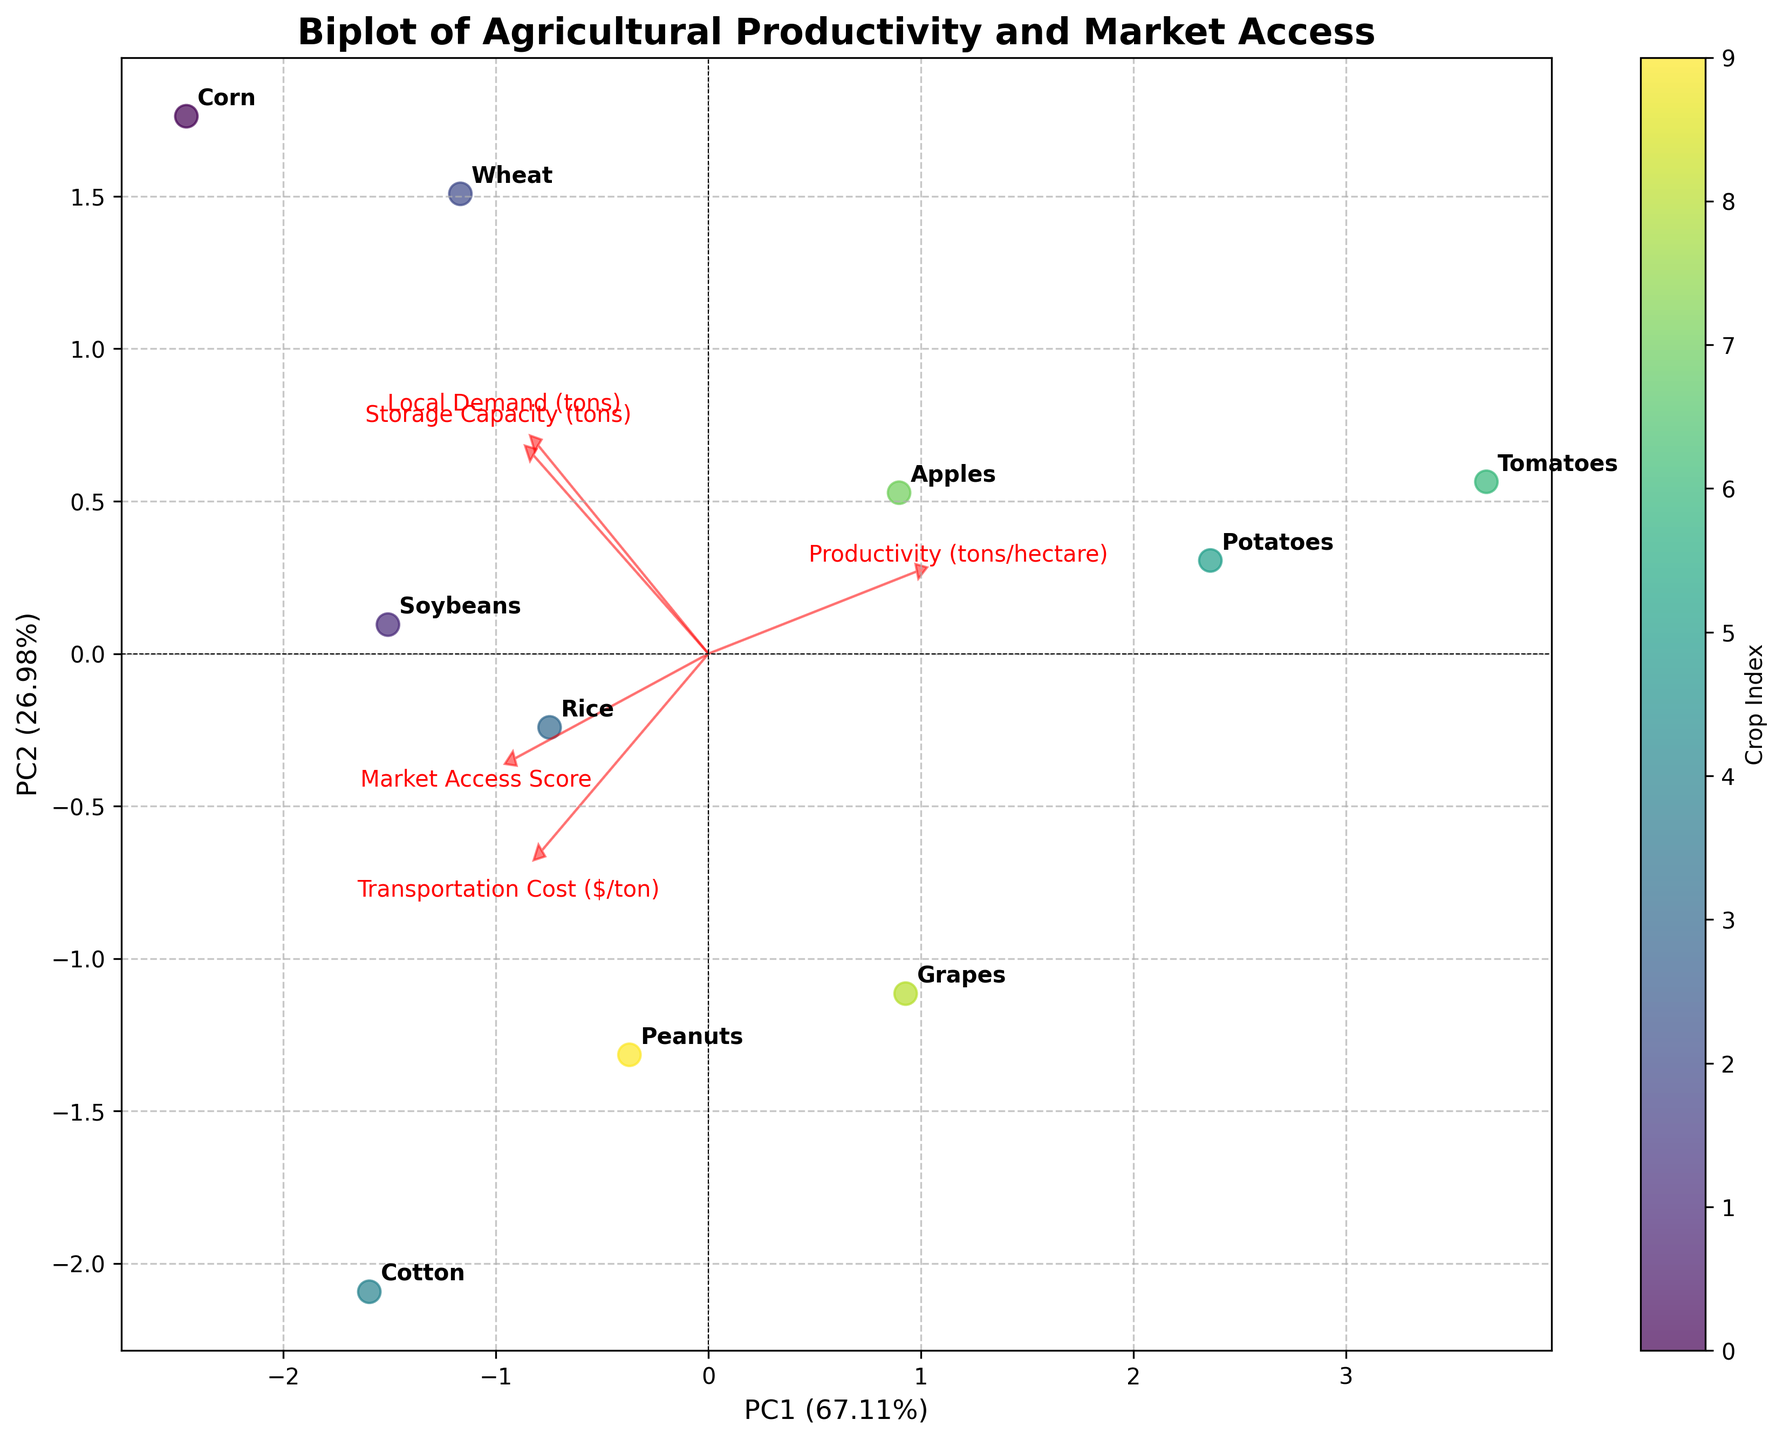What's the title of the figure? The title is usually placed at the top of the figure. From the description, the title is mentioned to be "Biplot of Agricultural Productivity and Market Access".
Answer: Biplot of Agricultural Productivity and Market Access What do the X and Y axes represent? The X-axis and Y-axis labels indicate Principal Components (PC1 and PC2). The exact text will be in the format “PC1 (percentage)” and “PC2 (percentage)”, reflecting the explained variance. From the code details, PC1 and PC2 are the leading components.
Answer: PC1 and PC2 Which crop appears to have the highest productivity? Crops are represented in the biplot with their names. A crop label that is farthest along the direction of the "Productivity" vector can be inferred as having high productivity. For this problem, "Tomatoes" is the crop with the highest productivity.
Answer: Tomatoes What crop has the lowest market access score? This can be determined by checking the crop label closest to the origin along the "Market Access Score" vector. From the data, "Tomatoes" have the lowest score.
Answer: Tomatoes Is there a crop that is closer to the origin in the biplot plot? If so, which one? The crop closest to the origin of the biplot can be seen as having average values for all the factors, where it manifests neither strong nor weak attributes in any direction. Comparing distances, it appears "Peanuts" are closest.
Answer: Peanuts Which principal component explains the most variance in the data? The labels on the X and Y axes typically denote explained variances, e.g., "PC1 (40%)". By comparing these labels, the principal component with the higher percentage denotes the one explaining more variance.
Answer: PC1 Which crop type has the highest local demand? The crops positioned farthest along the "Local Demand" vector in the biplot should have the highest local demand. According to the data, "Corn" has the highest local demand.
Answer: Corn How does transportation cost influence crop distribution in the biplot? The direction and length of the "Transportation Cost" arrow indicate its influence. Crops aligned in the arrow's direction face higher costs, while those opposite face lower costs. Crops like "Tomatoes" with lower costs position away from high transportation cost vector.
Answer: Higher costs align along the vector direction Do crops with high storage capacity tend to cluster together in the biplot? Intermediately in the biplot, if crops like "Corn" and "Wheat" yielding high storage capacity seem together, illustrating the clustering of crops with such traits.
Answer: Yes Which two vector loadings appear to have a similar direction, indicating correlated metrics? By observing vector directions, "Transportation Cost" and "Market Access Score" seem similar portraying correlation as both influence crop market dynamics.
Answer: Transportation Cost and Market Access Score 